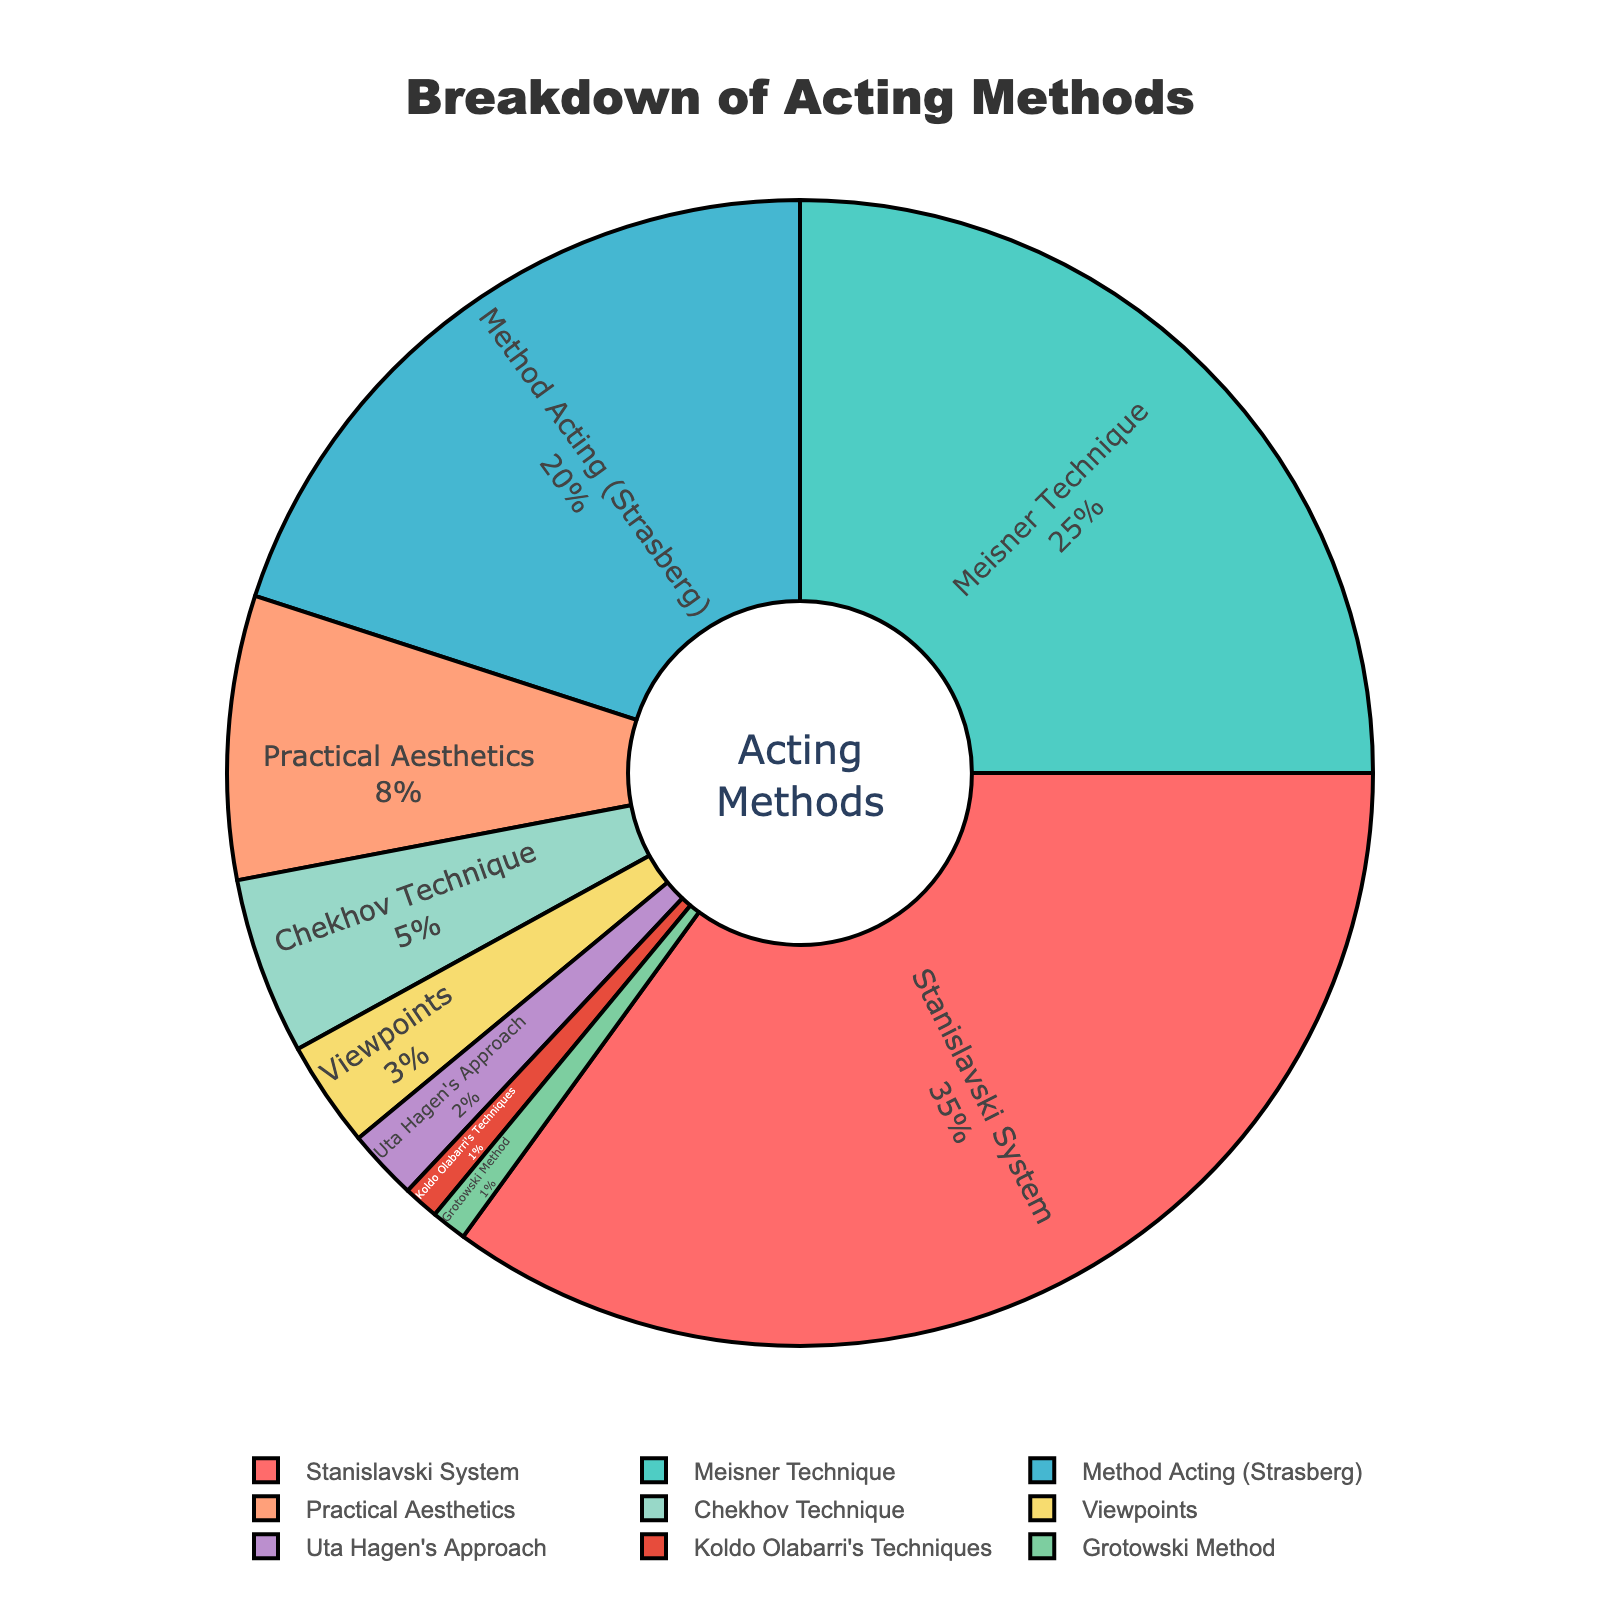Which acting method has the highest percentage? By looking at the pie chart, we can see that the Stanislavski System has the largest slice, occupying 35% of the total pie, which is more than any other method.
Answer: Stanislavski System What is the total percentage of actors studying Meisner Technique and Strasberg's Method Acting combined? Adding the percentages of the Meisner Technique (25%) and Strasberg's Method Acting (20%) gives us a combined total of 25% + 20% = 45%.
Answer: 45% Which acting methods have a percentage of less than 5%? Observing the pie chart, we can identify the methods less than 5% as Chekhov Technique (5%), Viewpoints (3%), Uta Hagen's Approach (2%), Koldo Olabarri's Techniques (1%), and Grotowski Method (1%).
Answer: Chekhov Technique, Viewpoints, Uta Hagen's Approach, Koldo Olabarri's Techniques, Grotowski Method How does the Practical Aesthetics method compare in percentage to the Meisner Technique? By comparing the percentages, we see Practical Aesthetics is at 8% and Meisner Technique is at 25%. The Meisner Technique has a higher percentage by 25% - 8% = 17%.
Answer: Meisner Technique has 17% more What is the combined percentage of all methods except the top three? Adding the percentages of all methods except Stanislavski System (35%), Meisner Technique (25%), and Method Acting (Strasberg) (20%), we get Practical Aesthetics (8%) + Chekhov Technique (5%) + Viewpoints (3%) + Uta Hagen's Approach (2%) + Koldo Olabarri's Techniques (1%) + Grotowski Method (1%) = 20%.
Answer: 20% Which two methods have the closest percentage of actors studying them? Observing the pie chart, we see that Koldo Olabarri's Techniques (1%) and Grotowski Method (1%) have the closest percentages, both being equal at 1%.
Answer: Koldo Olabarri's Techniques and Grotowski Method What is the visual difference between the slices representing the Stanislavski System and the Chekhov Technique? By examining the chart, the Stanislavski System slice is significantly larger, occupying 35%, while the Chekhov Technique slice is much smaller at 5%. This visual difference shows the Stanislavski System dominates in visual area.
Answer: Stanislavski System slice is much larger 